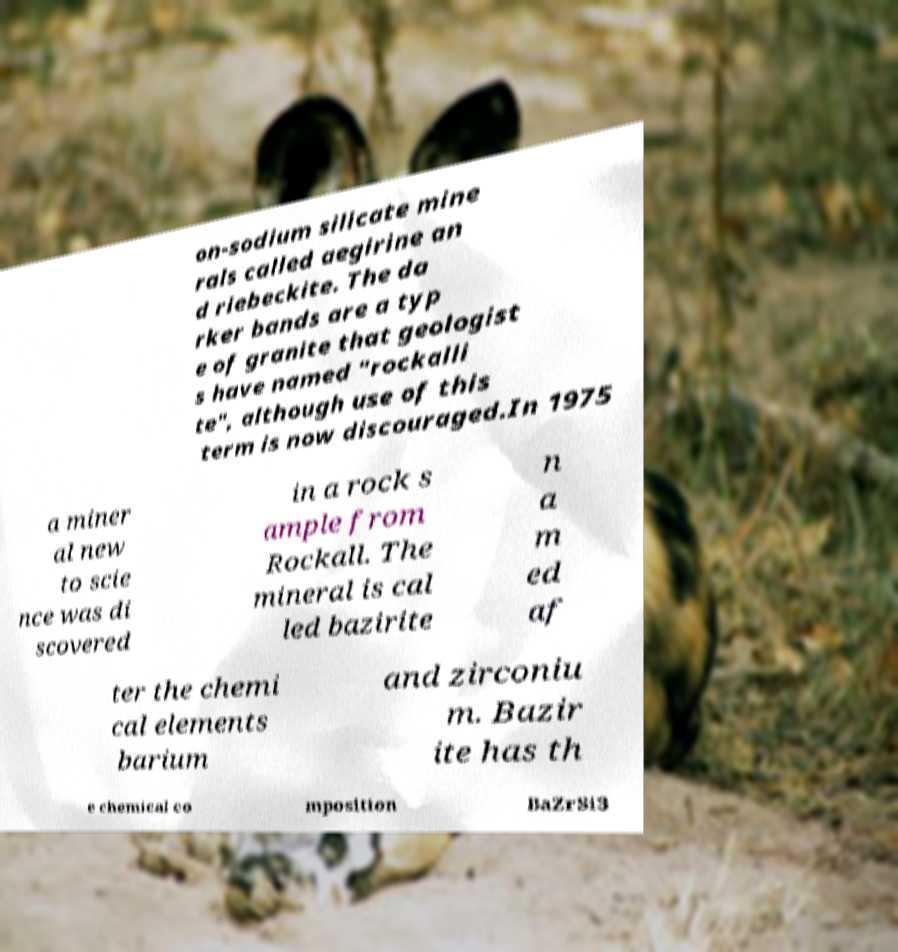There's text embedded in this image that I need extracted. Can you transcribe it verbatim? on-sodium silicate mine rals called aegirine an d riebeckite. The da rker bands are a typ e of granite that geologist s have named "rockalli te", although use of this term is now discouraged.In 1975 a miner al new to scie nce was di scovered in a rock s ample from Rockall. The mineral is cal led bazirite n a m ed af ter the chemi cal elements barium and zirconiu m. Bazir ite has th e chemical co mposition BaZrSi3 